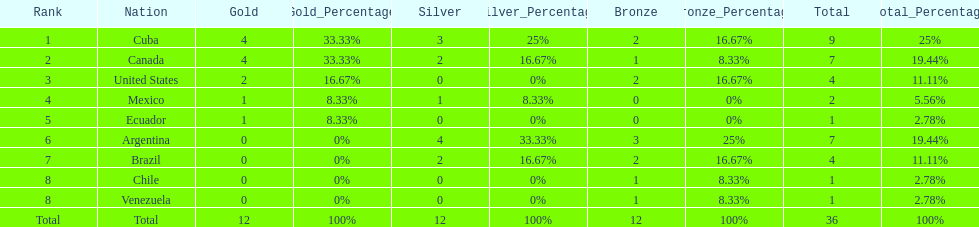What were the amounts of bronze medals won by the countries? 2, 1, 2, 0, 0, 3, 2, 1, 1. Which is the highest? 3. Which nation had this amount? Argentina. 